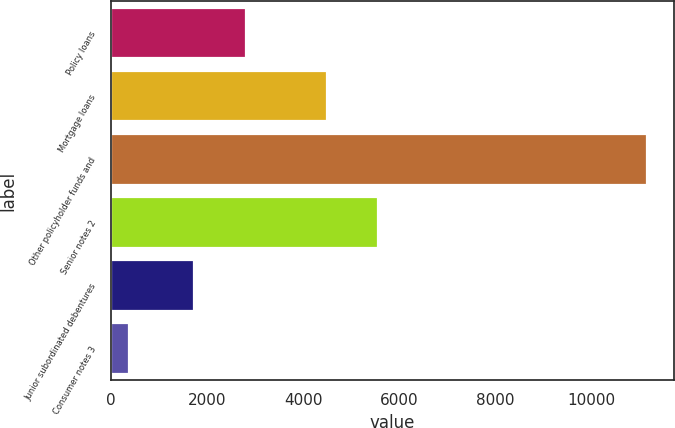<chart> <loc_0><loc_0><loc_500><loc_500><bar_chart><fcel>Policy loans<fcel>Mortgage loans<fcel>Other policyholder funds and<fcel>Senior notes 2<fcel>Junior subordinated debentures<fcel>Consumer notes 3<nl><fcel>2804.8<fcel>4489<fcel>11155<fcel>5566.8<fcel>1727<fcel>377<nl></chart> 